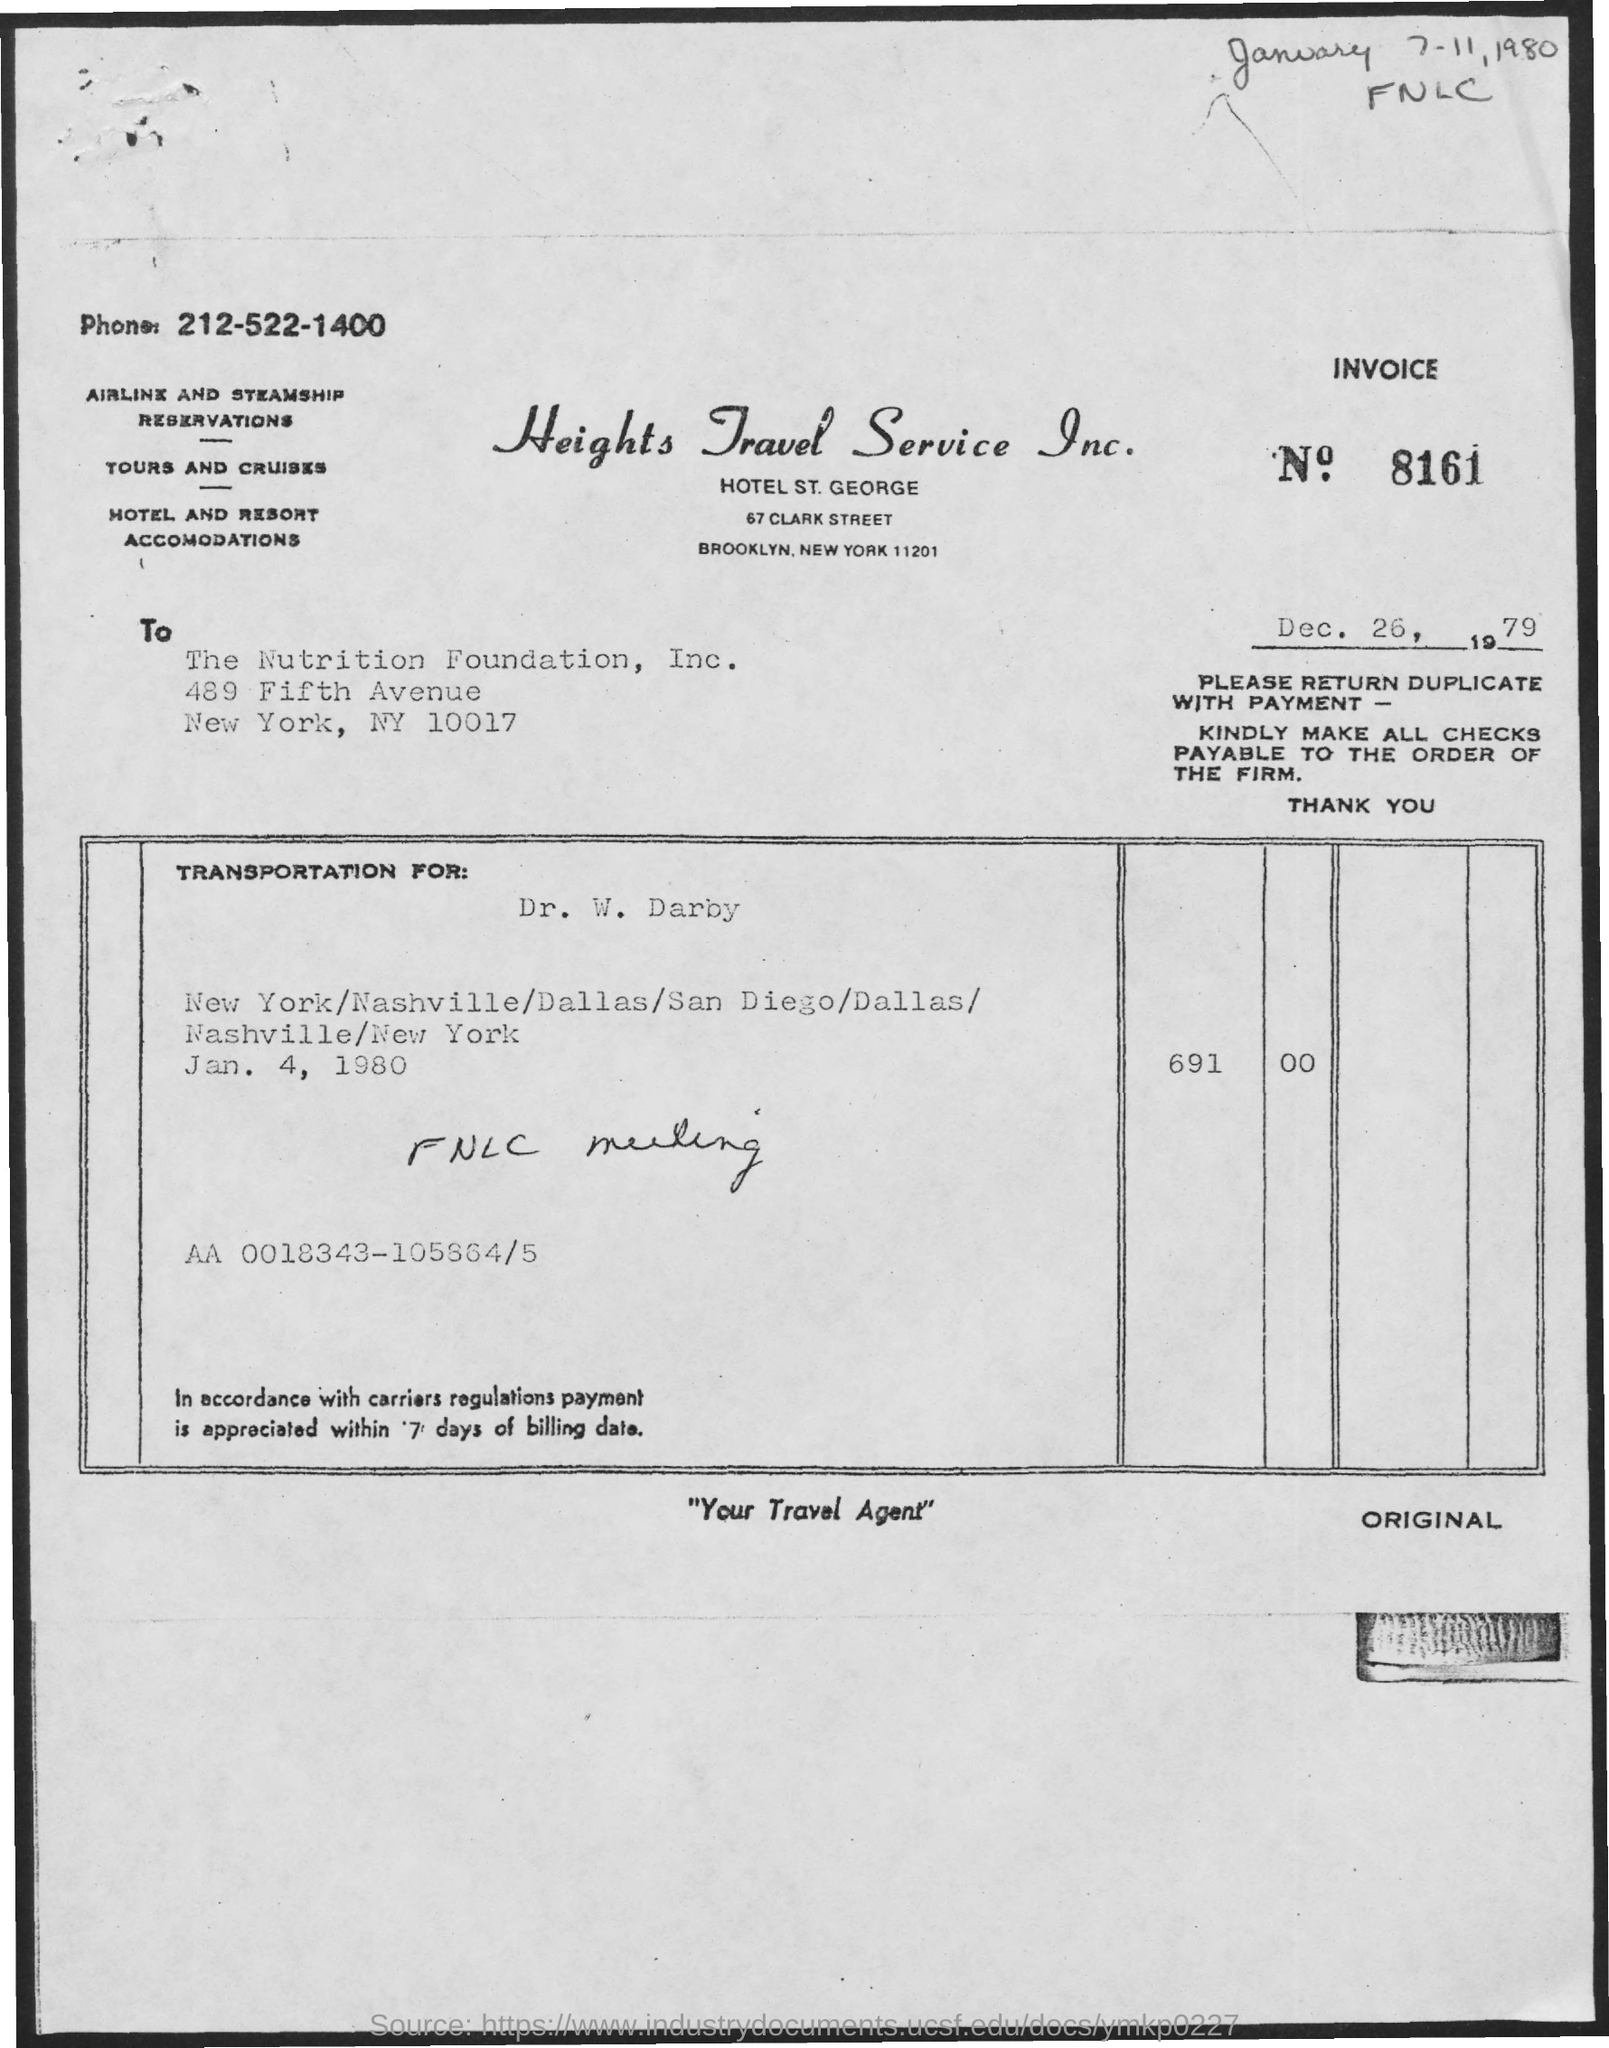Who is mentioned in the to ?
Offer a terse response. The Nutrition Foundation ,Inc. What is the date mentioned ?
Give a very brief answer. Dec. 26 , 1979. What is the invoice no
Offer a terse response. 8161. What is the phone number ?
Your answer should be very brief. 212-522-1400. Whose name is mentioned in the transportation for ?
Provide a succinct answer. Dr. W. Darby. What is the transportation date mentioned ?
Keep it short and to the point. Jan 4 , 1980. In which city the nutrition foundation , Inc is located
Your answer should be very brief. New york. 